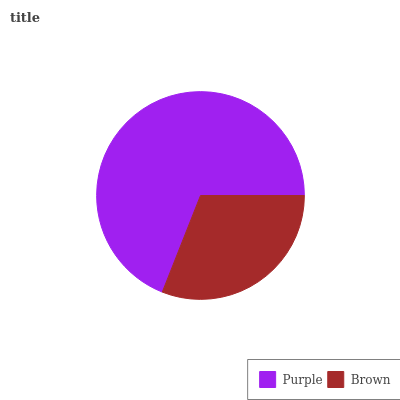Is Brown the minimum?
Answer yes or no. Yes. Is Purple the maximum?
Answer yes or no. Yes. Is Brown the maximum?
Answer yes or no. No. Is Purple greater than Brown?
Answer yes or no. Yes. Is Brown less than Purple?
Answer yes or no. Yes. Is Brown greater than Purple?
Answer yes or no. No. Is Purple less than Brown?
Answer yes or no. No. Is Purple the high median?
Answer yes or no. Yes. Is Brown the low median?
Answer yes or no. Yes. Is Brown the high median?
Answer yes or no. No. Is Purple the low median?
Answer yes or no. No. 